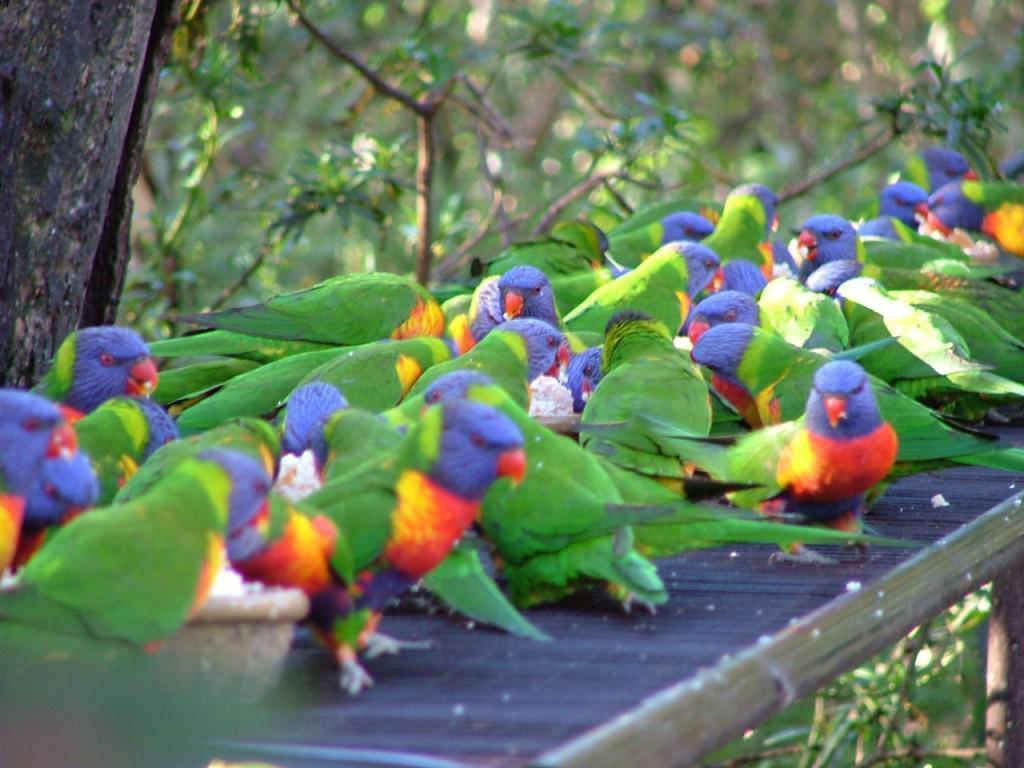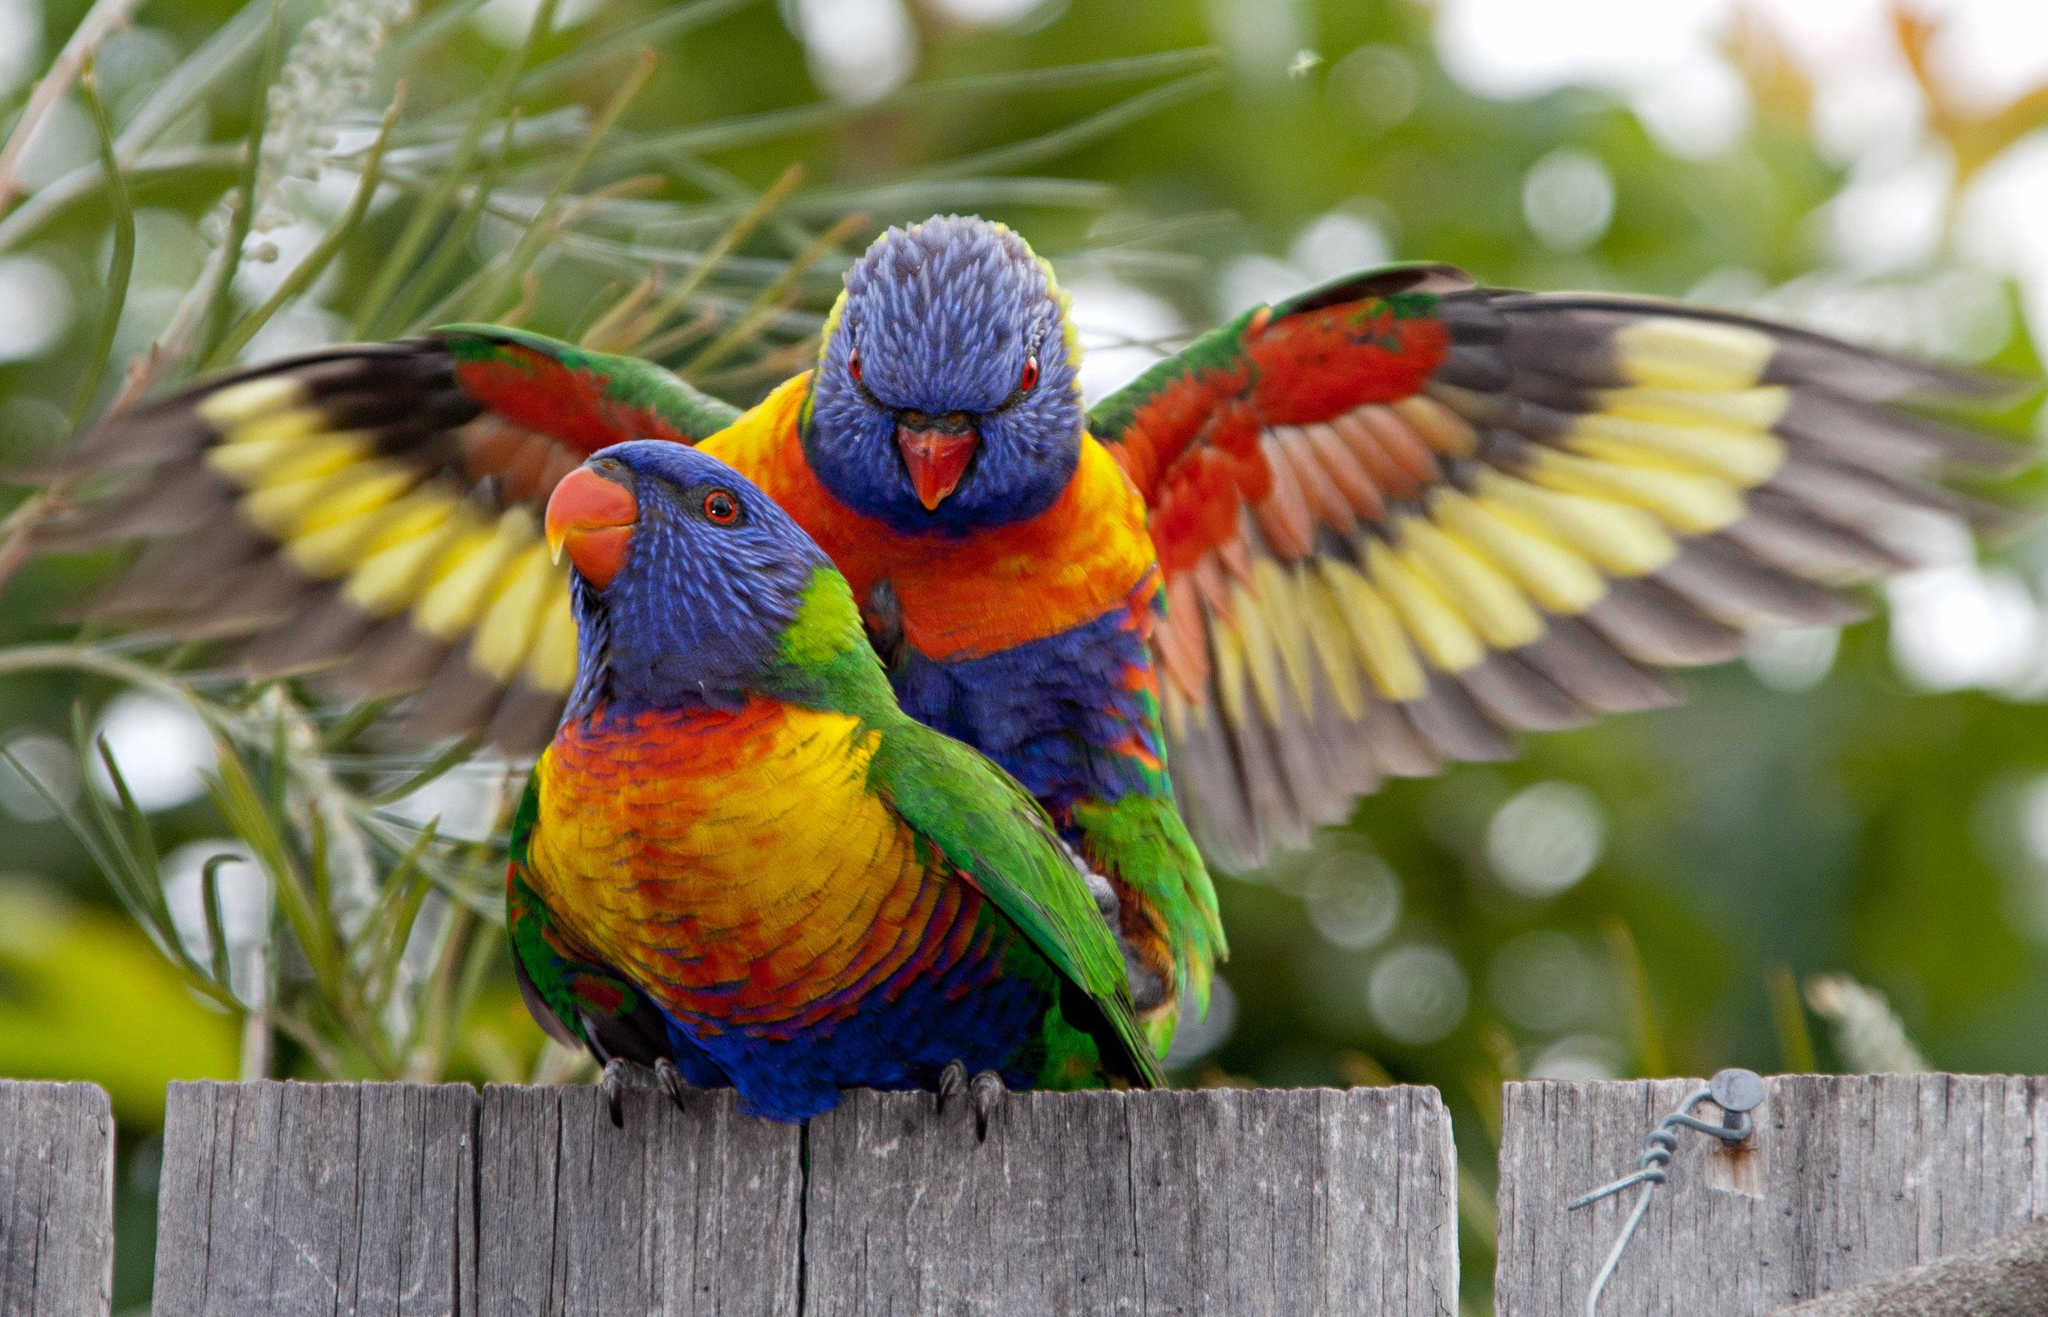The first image is the image on the left, the second image is the image on the right. For the images shown, is this caption "One image contains an entire flock of birds, 5 or more." true? Answer yes or no. Yes. The first image is the image on the left, the second image is the image on the right. For the images shown, is this caption "One bird stands alone." true? Answer yes or no. No. 